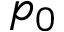Convert formula to latex. <formula><loc_0><loc_0><loc_500><loc_500>p _ { 0 }</formula> 